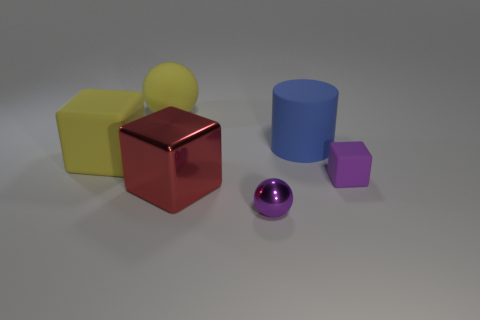How many other things are the same shape as the purple shiny thing?
Offer a terse response. 1. What number of small objects are either matte spheres or red cylinders?
Provide a short and direct response. 0. There is a block that is in front of the tiny purple matte object; is it the same color as the small block?
Keep it short and to the point. No. Do the large rubber thing that is to the right of the small sphere and the cube to the right of the large blue matte thing have the same color?
Make the answer very short. No. Is there another tiny cyan block made of the same material as the small block?
Make the answer very short. No. How many gray things are either big matte spheres or rubber objects?
Your answer should be compact. 0. Are there more big red objects behind the big blue matte cylinder than large cubes?
Keep it short and to the point. No. Is the size of the yellow cube the same as the red metallic cube?
Make the answer very short. Yes. The tiny cube that is made of the same material as the blue cylinder is what color?
Offer a very short reply. Purple. The large matte object that is the same color as the rubber ball is what shape?
Make the answer very short. Cube. 